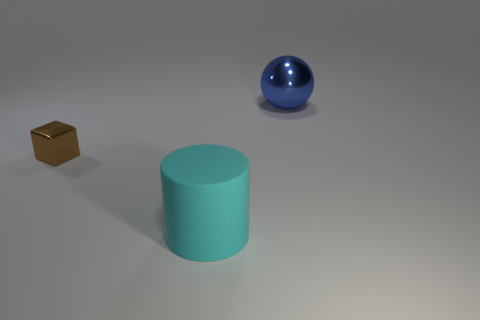Add 2 big yellow matte blocks. How many objects exist? 5 Subtract all red spheres. Subtract all gray cylinders. How many spheres are left? 1 Subtract all blocks. How many objects are left? 2 Subtract all cyan rubber balls. Subtract all large cyan matte things. How many objects are left? 2 Add 1 brown cubes. How many brown cubes are left? 2 Add 2 small cyan matte cylinders. How many small cyan matte cylinders exist? 2 Subtract 0 brown spheres. How many objects are left? 3 